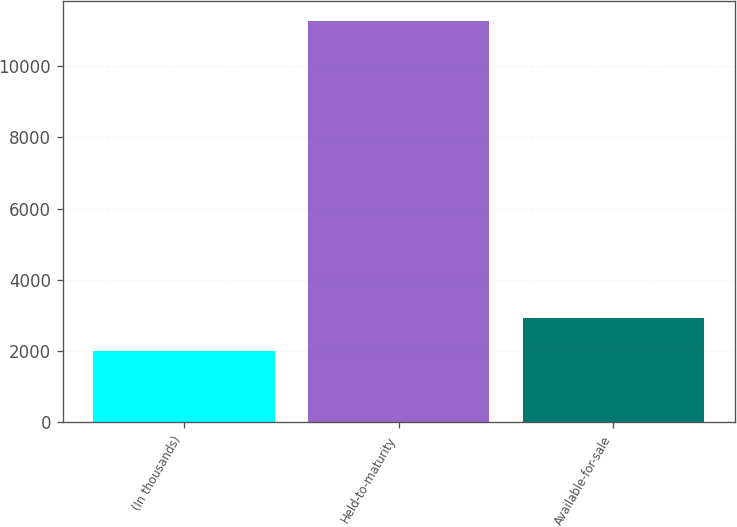Convert chart. <chart><loc_0><loc_0><loc_500><loc_500><bar_chart><fcel>(In thousands)<fcel>Held-to-maturity<fcel>Available-for-sale<nl><fcel>2014<fcel>11264<fcel>2939<nl></chart> 